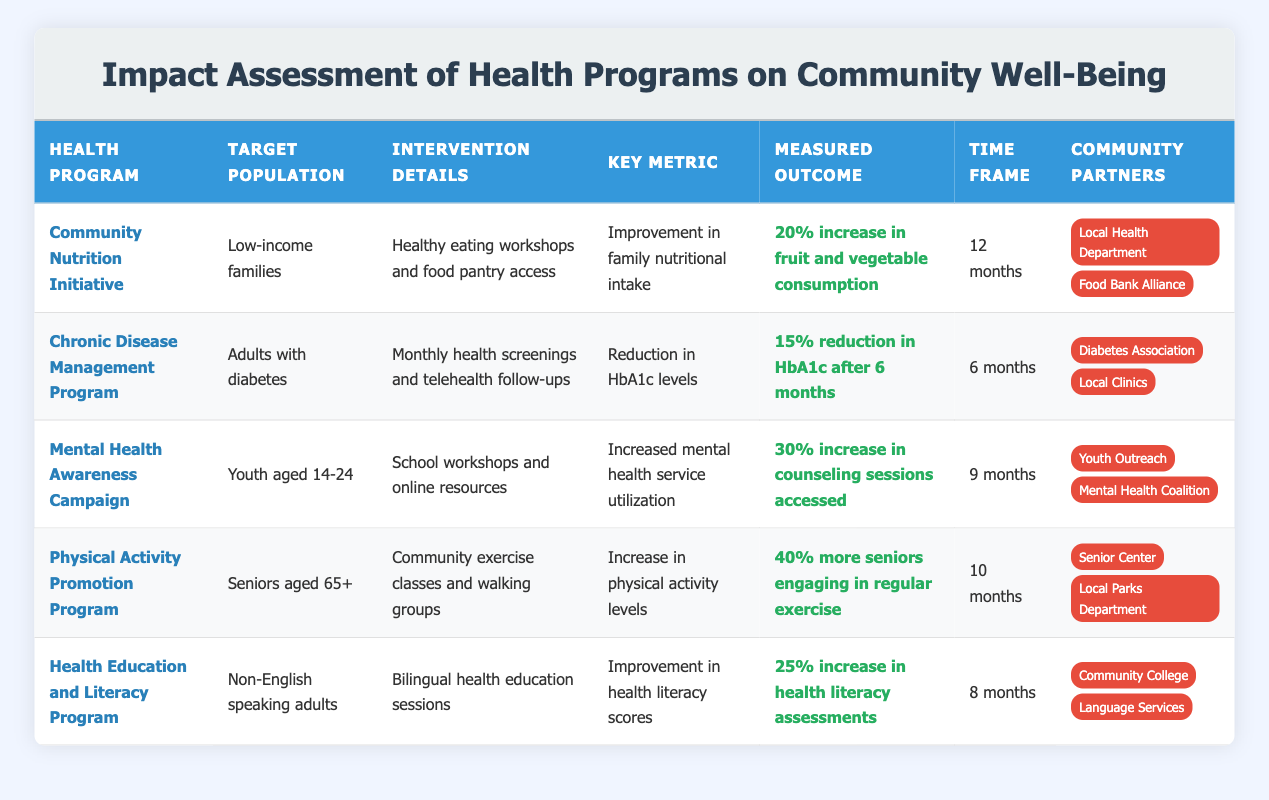What is the target population for the Community Nutrition Initiative? The target population is listed in the table under the "Target Population" column for the Community Nutrition Initiative. It states "Low-income families."
Answer: Low-income families Which health program has the highest percentage increase in measured outcomes? The Program with the highest percentage increase in measured outcomes is the Physical Activity Promotion Program, which shows a "40% more seniors engaging in regular exercise." This is higher than the other programs’ outcomes.
Answer: Physical Activity Promotion Program Is the Chronic Disease Management Program focused on youth? Looking at the "Target Population" for the Chronic Disease Management Program, it states "Adults with diabetes," which indicates it is not focused on youth.
Answer: No What is the average percentage increase in measured outcomes across all programs? To find the average, we sum the increases: 20% + 15% + 30% + 40% + 25% = 130%. The number of programs is 5, so the average is 130% / 5 = 26%.
Answer: 26% How many months does the Community Nutrition Initiative take to show its measured outcome? The time frame is provided in the "Time Frame" column for the Community Nutrition Initiative, which states it takes "12 months" to show the measured outcome.
Answer: 12 months Which health program partners with both a health department and a food bank? The Community Nutrition Initiative partners with the "Local Health Department" and "Food Bank Alliance," making it the program that collaborates with both types of organizations.
Answer: Community Nutrition Initiative Is there any program targeting seniors? The "Physical Activity Promotion Program" targets seniors aged 65+, which confirms that there is a program specifically tailored for that age group.
Answer: Yes What percentage increase in health literacy assessments does the Health Education and Literacy Program achieve? The measured outcome specified in the table for the Health Education and Literacy Program indicates a "25% increase in health literacy assessments."
Answer: 25% 